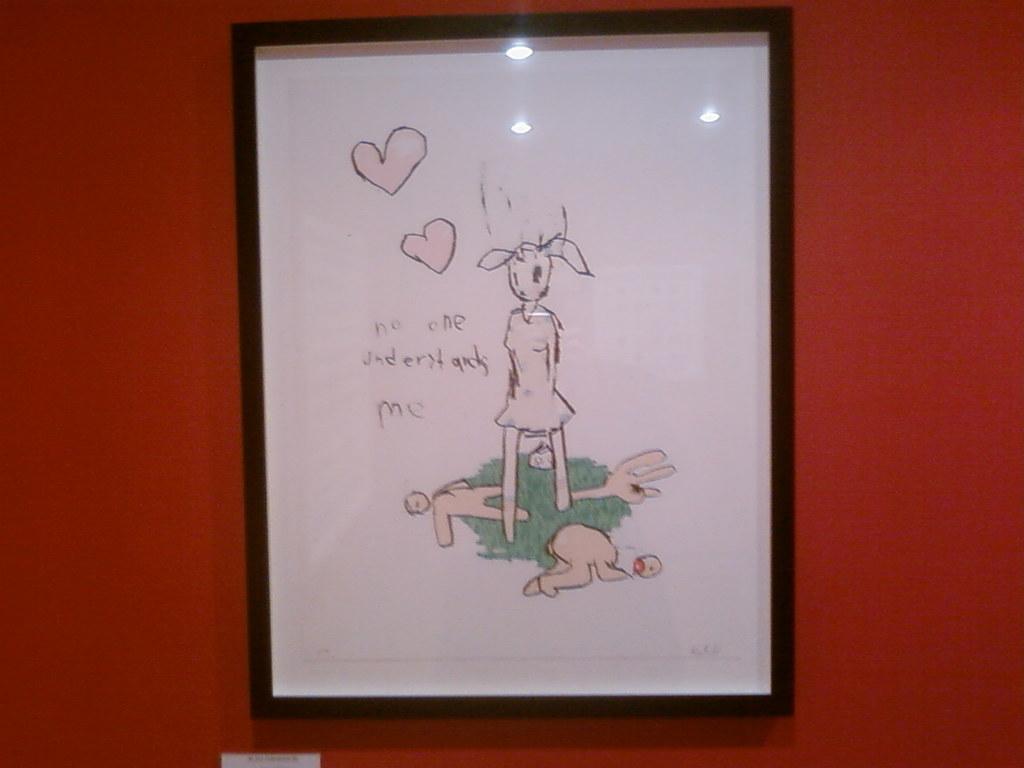Who understands me?
Give a very brief answer. No one. What is the writing on the drawing?
Your answer should be very brief. No one understands me. 